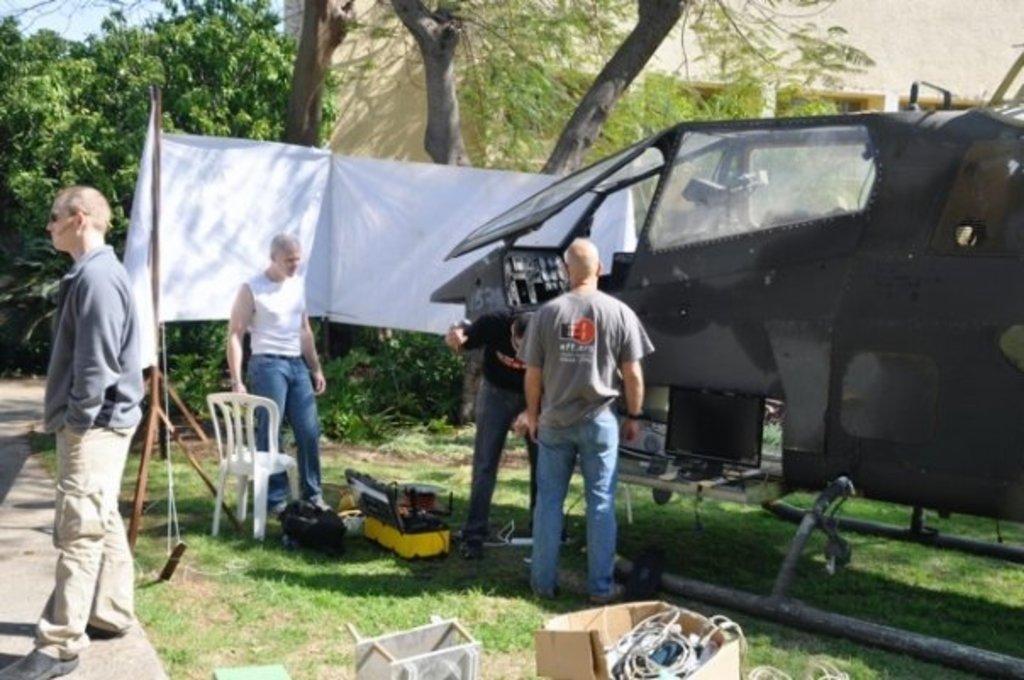Please provide a concise description of this image. In this image we can see some group of persons standing near the helicopter and doing some work there is chair, some cardboard boxes on the ground and at the background of the image there are some trees and building. 